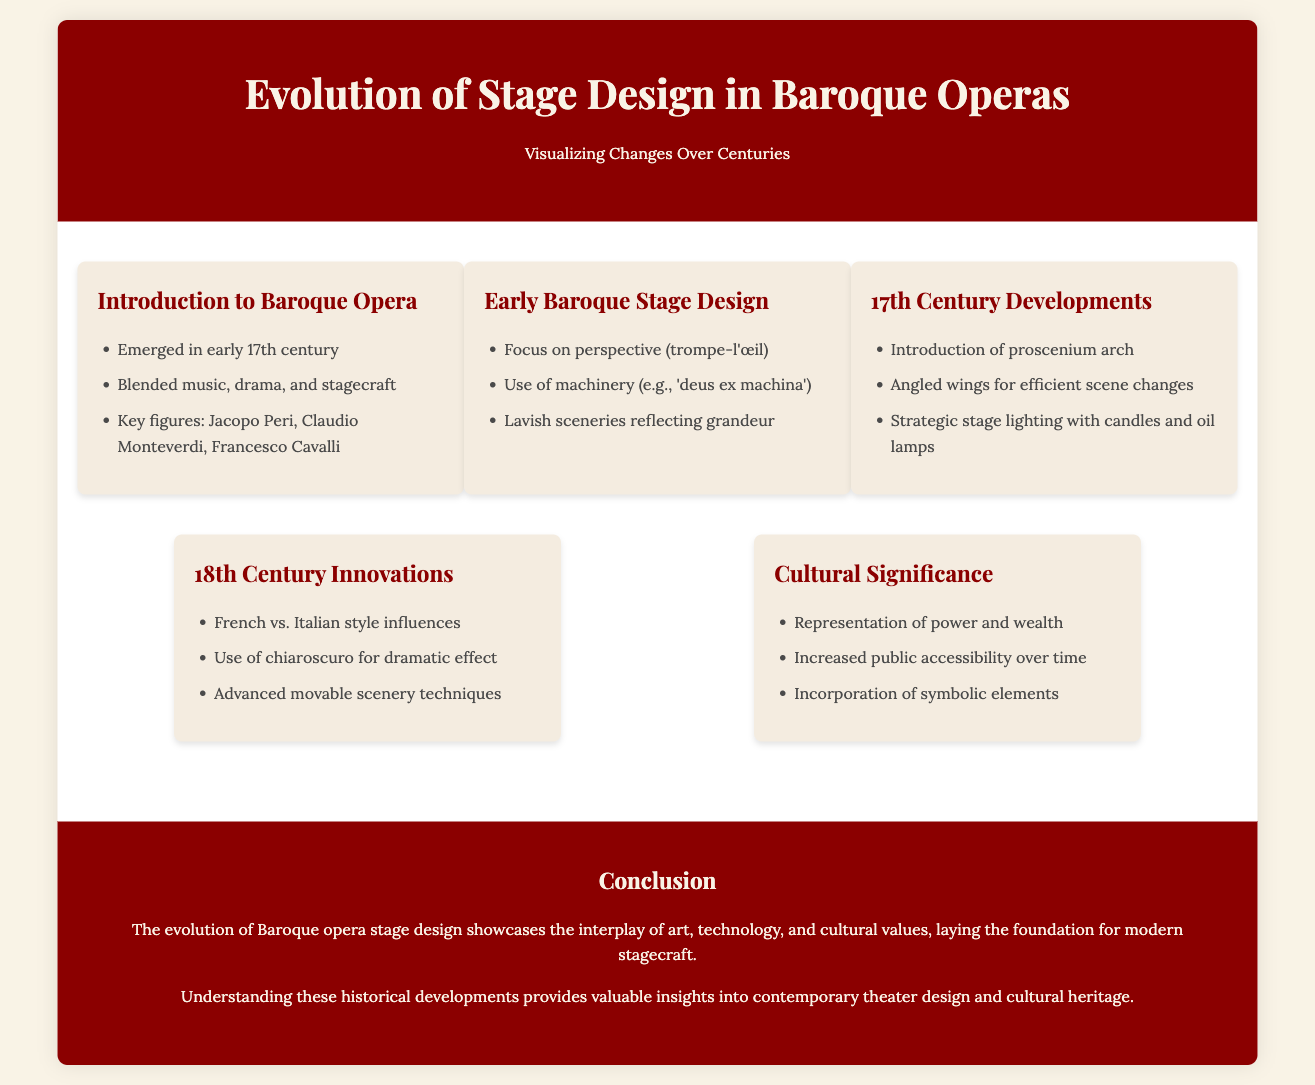what year did Baroque opera emerge? The document states that Baroque opera emerged in the early 17th century.
Answer: early 17th century which key figure is associated with Baroque opera? The document lists Jacopo Peri, Claudio Monteverdi, and Francesco Cavalli as key figures in Baroque opera.
Answer: Jacopo Peri what stage design technique was introduced in the 17th century? The document mentions the introduction of the proscenium arch in the 17th century.
Answer: proscenium arch how did stage lighting change in the 17th century? The timeline states that the strategic stage lighting evolved with the use of candles and oil lamps in the 17th century.
Answer: candles and oil lamps what is one cultural significance of Baroque opera staging? The document highlights the representation of power and wealth as a cultural significance of Baroque opera staging.
Answer: power and wealth which two styles influenced 18th-century stage design? The document notes that French and Italian style influences impacted 18th-century stage design.
Answer: French and Italian what does 'chiaroscuro' refer to in 18th-century innovations? The document states that chiaroscuro was used for dramatic effect in 18th-century stage design.
Answer: dramatic effect what is the main theme of the conclusion? The conclusion emphasizes the interplay of art, technology, and cultural values in the evolution of Baroque opera stage design.
Answer: interplay of art, technology, and cultural values what does understanding historical developments provide insights into? According to the document, understanding historical developments provides valuable insights into contemporary theater design and cultural heritage.
Answer: contemporary theater design and cultural heritage 